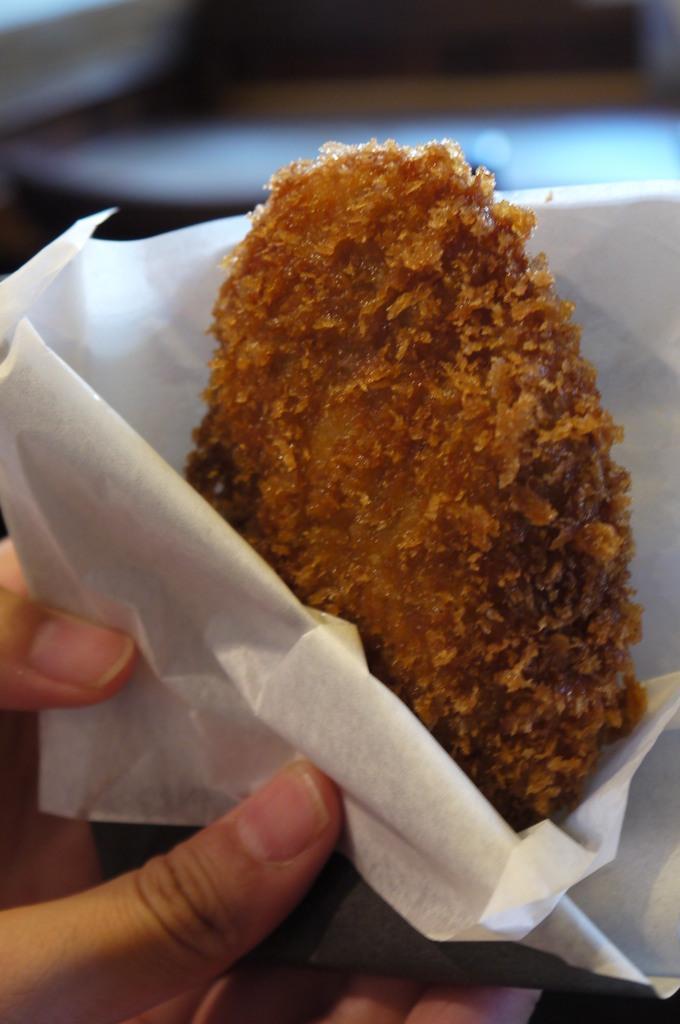Please provide a concise description of this image. In this image we can see hands of a person holding food item with tissue papers. There is a blur background. 